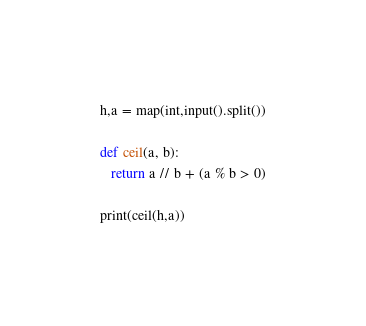<code> <loc_0><loc_0><loc_500><loc_500><_Python_>h,a = map(int,input().split())

def ceil(a, b):
   return a // b + (a % b > 0)

print(ceil(h,a))</code> 